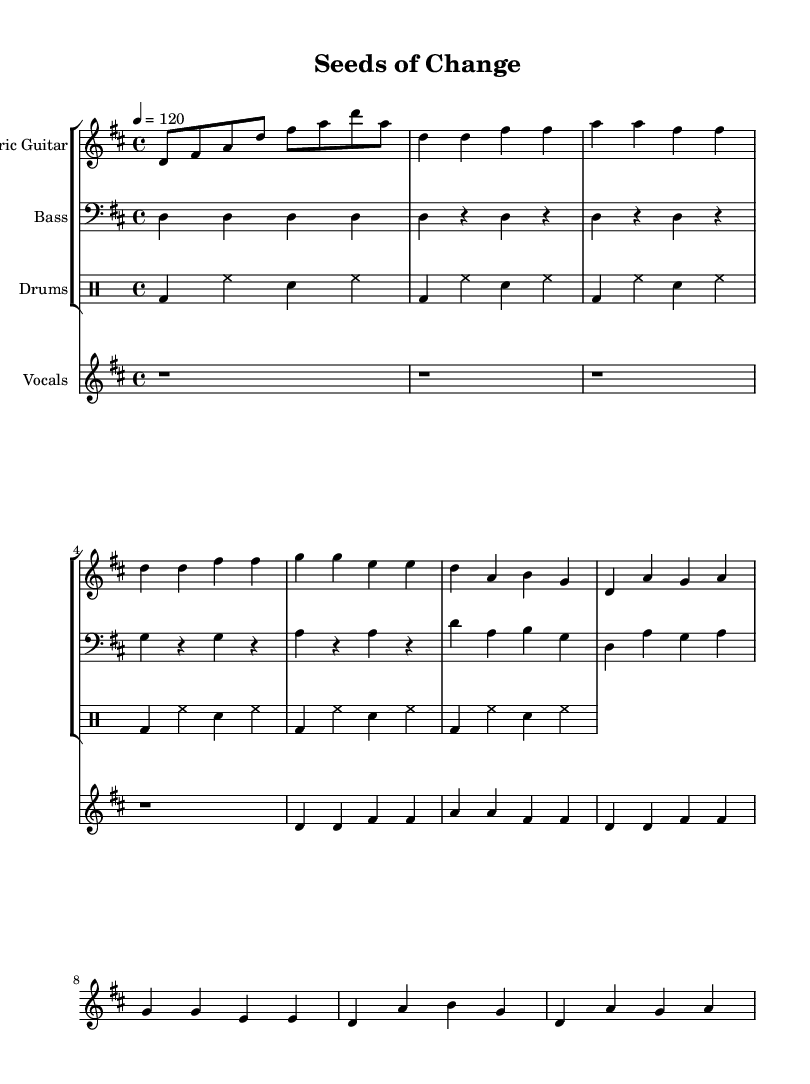What is the key signature of this music? The key signature is one sharp, indicating it is in D major. This can be confirmed by looking at the 'global' section where it states '\key d \major'.
Answer: D major What is the time signature of this music? The time signature is four beats per measure, as indicated by the '\time 4/4' in the 'global' section. This means each measure contains four quarter note beats.
Answer: 4/4 What is the tempo marking of this piece? The tempo marking is set to a quarter note equal to 120 beats per minute, as indicated by '\tempo 4 = 120' in the global section. This establishes how fast the piece should be performed.
Answer: 120 How many measures are in the verse section? The verse section has eight measures as identified by counting each measure in the 'electricGuitar' part from the section labeled as 'Verse'.
Answer: 8 What is the primary theme of the lyrics in this song? The primary theme is about sustainable farming and advocating for practices that benefit the environment, as noted in the lyrics "Planting seeds of wisdom in the fertile ground."
Answer: Sustainable farming What determines the rock style of this song? The use of electric guitars and a strong backbeat from the drums establishes the rock style, which is evident in the instrumentation and structure outlined in the score. The presence of the "basic rock beat" also reinforces this genre characteristic.
Answer: Electric guitars and strong drums What is the structure of the song based on the sections identified? The structure consists of an introductory part, followed by verses and a chorus, which is typical in rock music, providing a clear pattern within the composition. This can be seen in the labeled parts and repeated sections throughout the score.
Answer: Intro, Verse, Chorus 